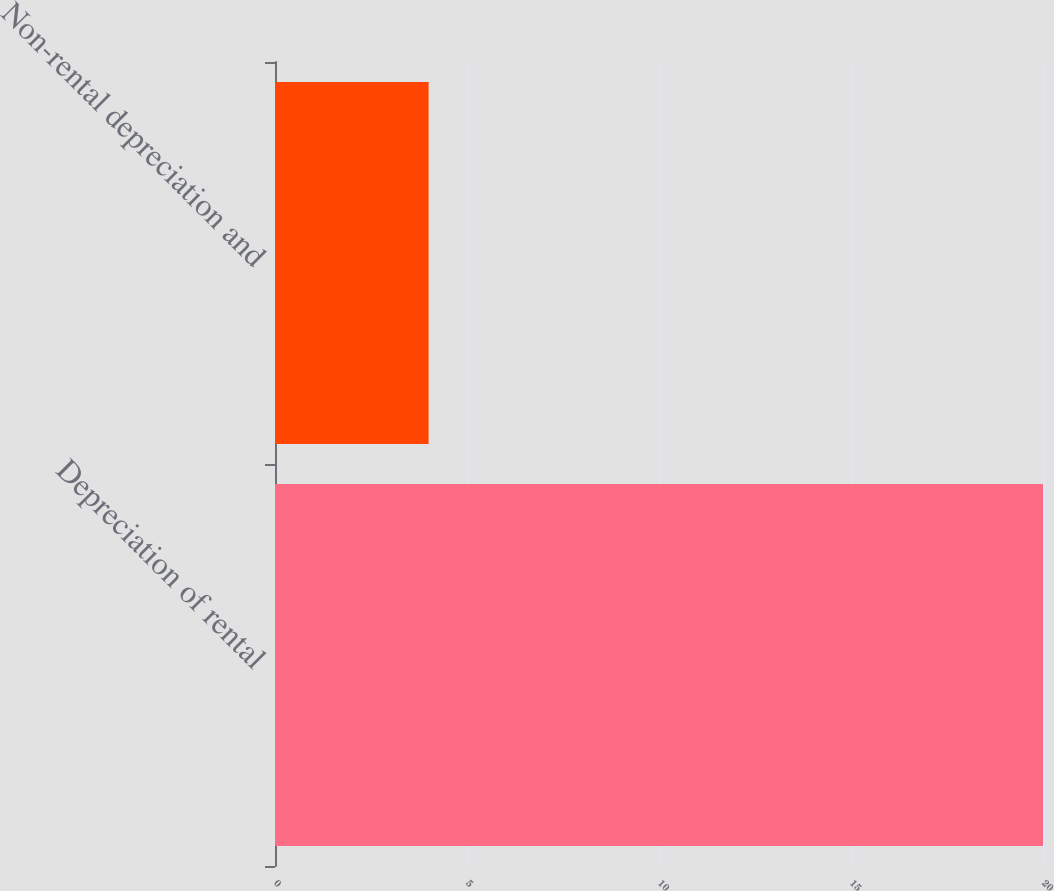Convert chart. <chart><loc_0><loc_0><loc_500><loc_500><bar_chart><fcel>Depreciation of rental<fcel>Non-rental depreciation and<nl><fcel>20<fcel>4<nl></chart> 